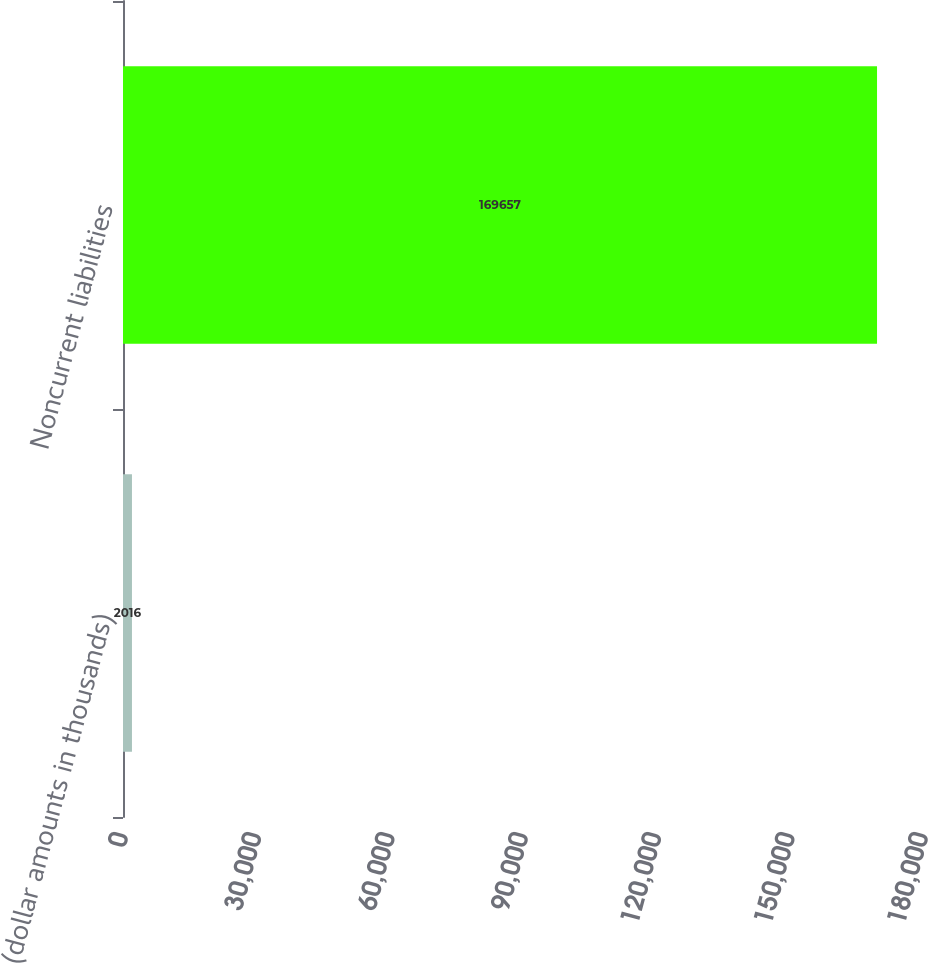<chart> <loc_0><loc_0><loc_500><loc_500><bar_chart><fcel>(dollar amounts in thousands)<fcel>Noncurrent liabilities<nl><fcel>2016<fcel>169657<nl></chart> 